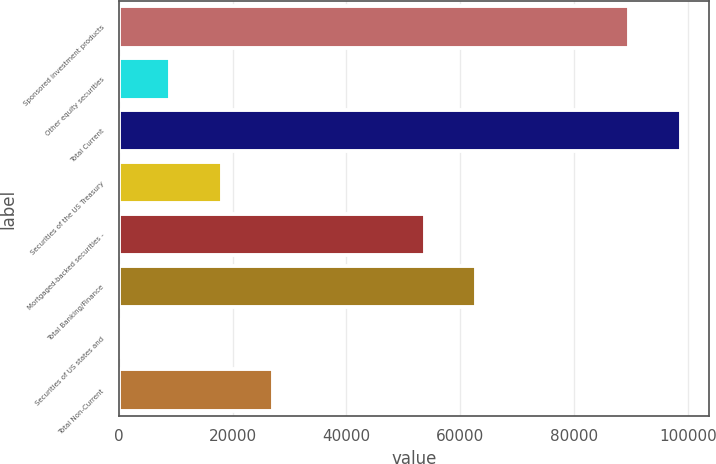Convert chart to OTSL. <chart><loc_0><loc_0><loc_500><loc_500><bar_chart><fcel>Sponsored investment products<fcel>Other equity securities<fcel>Total Current<fcel>Securities of the US Treasury<fcel>Mortgaged-backed securities -<fcel>Total Banking/Finance<fcel>Securities of US states and<fcel>Total Non-Current<nl><fcel>89676<fcel>9048.64<fcel>98721.5<fcel>18094.1<fcel>53717<fcel>62762.5<fcel>3.15<fcel>27139.6<nl></chart> 